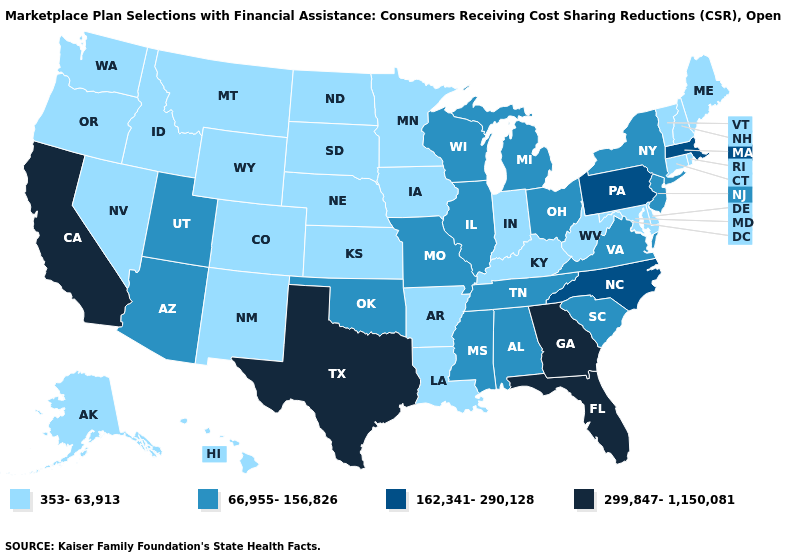Which states hav the highest value in the South?
Write a very short answer. Florida, Georgia, Texas. Name the states that have a value in the range 66,955-156,826?
Concise answer only. Alabama, Arizona, Illinois, Michigan, Mississippi, Missouri, New Jersey, New York, Ohio, Oklahoma, South Carolina, Tennessee, Utah, Virginia, Wisconsin. Name the states that have a value in the range 162,341-290,128?
Give a very brief answer. Massachusetts, North Carolina, Pennsylvania. What is the highest value in the USA?
Concise answer only. 299,847-1,150,081. Which states hav the highest value in the MidWest?
Write a very short answer. Illinois, Michigan, Missouri, Ohio, Wisconsin. Among the states that border New York , which have the lowest value?
Give a very brief answer. Connecticut, Vermont. What is the value of California?
Be succinct. 299,847-1,150,081. Does Georgia have the highest value in the USA?
Keep it brief. Yes. Does the map have missing data?
Give a very brief answer. No. Does Virginia have a lower value than Florida?
Quick response, please. Yes. Does Arkansas have the highest value in the USA?
Write a very short answer. No. Does Alabama have the highest value in the USA?
Write a very short answer. No. Does Missouri have a higher value than New Hampshire?
Give a very brief answer. Yes. Does Maine have the highest value in the Northeast?
Quick response, please. No. What is the highest value in the South ?
Answer briefly. 299,847-1,150,081. 